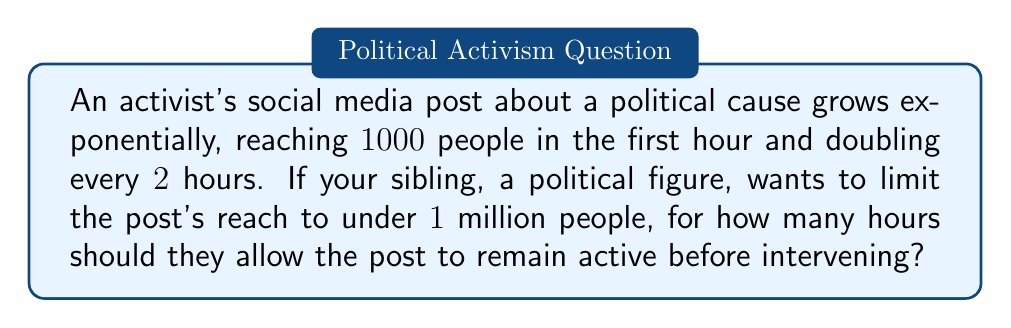Show me your answer to this math problem. Let's approach this step-by-step:

1) The initial reach is $1000$ people, and it doubles every $2$ hours.

2) Let $n$ be the number of 2-hour periods. Then the reach after $n$ periods (or $2n$ hours) is:

   $1000 \cdot 2^n$

3) We want to find the largest $n$ for which this is less than 1 million:

   $1000 \cdot 2^n < 1,000,000$

4) Dividing both sides by 1000:

   $2^n < 1000$

5) Taking $\log_2$ of both sides:

   $n < \log_2(1000)$

6) $\log_2(1000) \approx 9.97$

7) Since $n$ must be an integer (we can't have a fractional number of 2-hour periods), the largest value of $n$ that satisfies the inequality is 9.

8) Remember, $n$ represents the number of 2-hour periods. To get the number of hours, we multiply by 2:

   $9 \cdot 2 = 18$ hours

Therefore, the post should be allowed to remain active for 18 hours before intervention.
Answer: 18 hours 